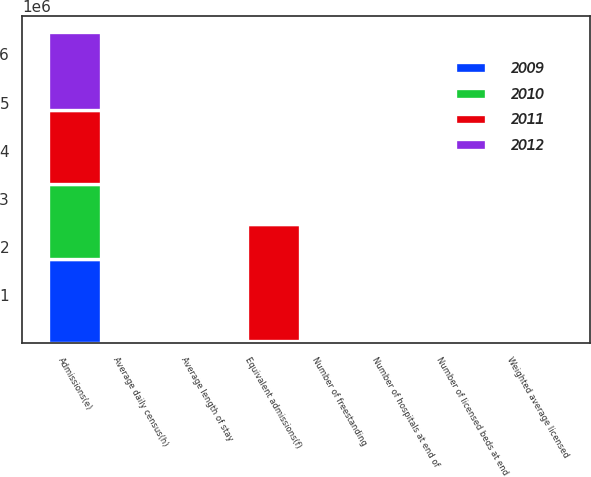<chart> <loc_0><loc_0><loc_500><loc_500><stacked_bar_chart><ecel><fcel>Number of hospitals at end of<fcel>Number of freestanding<fcel>Number of licensed beds at end<fcel>Weighted average licensed<fcel>Admissions(e)<fcel>Equivalent admissions(f)<fcel>Average length of stay<fcel>Average daily census(h)<nl><fcel>2009<fcel>162<fcel>112<fcel>41804<fcel>41795<fcel>1.7407e+06<fcel>21123<fcel>4.7<fcel>22521<nl><fcel>2012<fcel>163<fcel>108<fcel>41594<fcel>39735<fcel>1.6204e+06<fcel>21123<fcel>4.8<fcel>21123<nl><fcel>2010<fcel>156<fcel>97<fcel>38827<fcel>38655<fcel>1.5544e+06<fcel>21123<fcel>4.8<fcel>20523<nl><fcel>2011<fcel>155<fcel>97<fcel>38839<fcel>38825<fcel>1.5565e+06<fcel>2.439e+06<fcel>4.8<fcel>20650<nl></chart> 